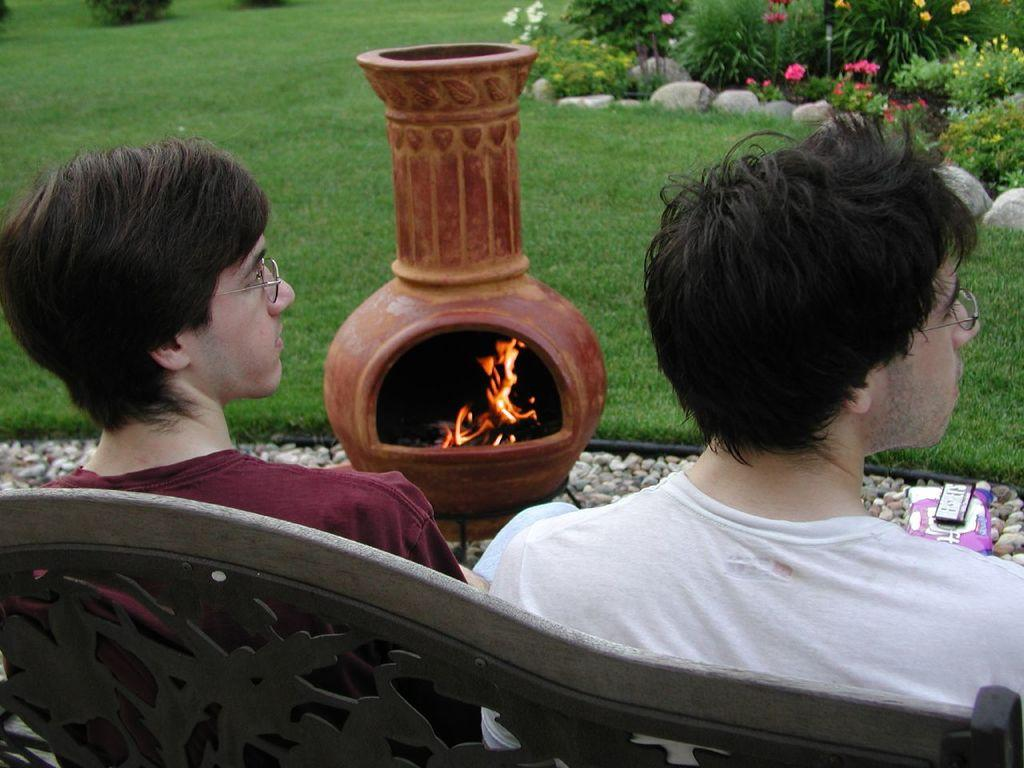How many people are sitting on the bench in the image? There are two persons sitting on a bench in the image. What type of natural elements can be seen in the image? There are stones, grass, plants, and flowers in the image. Is there any fire visible in the image? Yes, there is fire in the image. What other objects can be seen in the image besides the bench and the people sitting on it? There are other objects in the image. Can you tell me the account number of the beggar in the image? There is no beggar present in the image, and therefore no account number can be provided. 